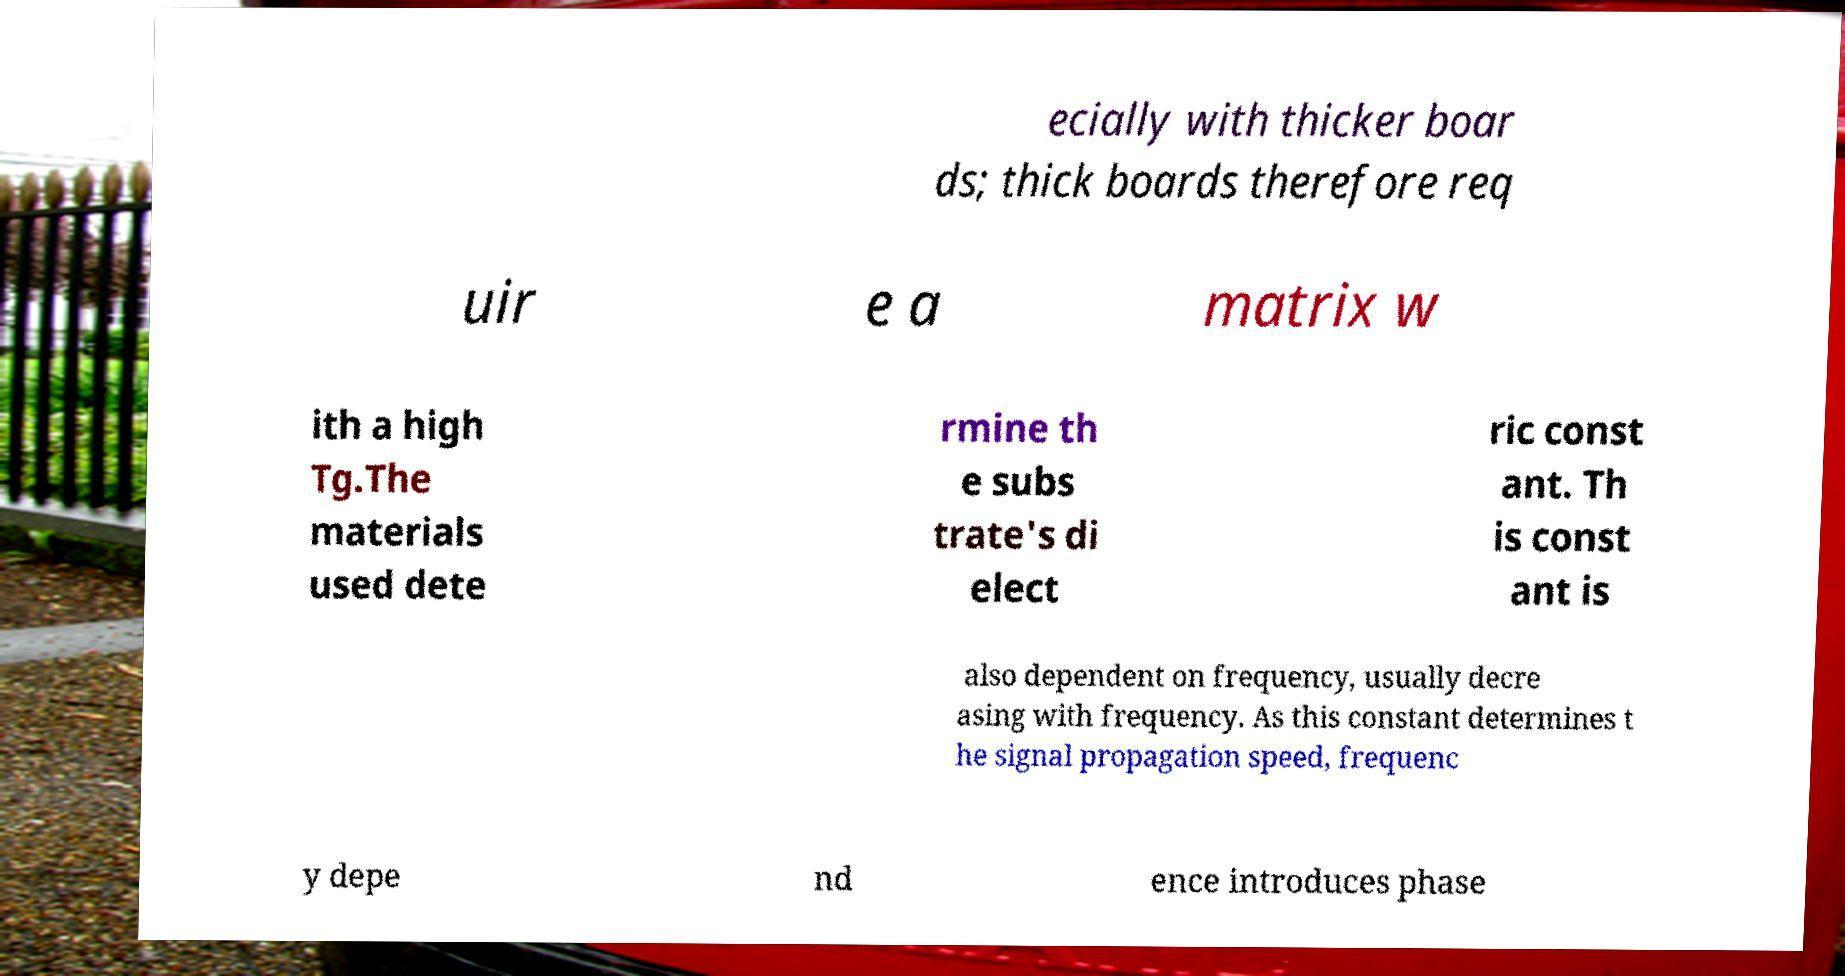Please identify and transcribe the text found in this image. ecially with thicker boar ds; thick boards therefore req uir e a matrix w ith a high Tg.The materials used dete rmine th e subs trate's di elect ric const ant. Th is const ant is also dependent on frequency, usually decre asing with frequency. As this constant determines t he signal propagation speed, frequenc y depe nd ence introduces phase 